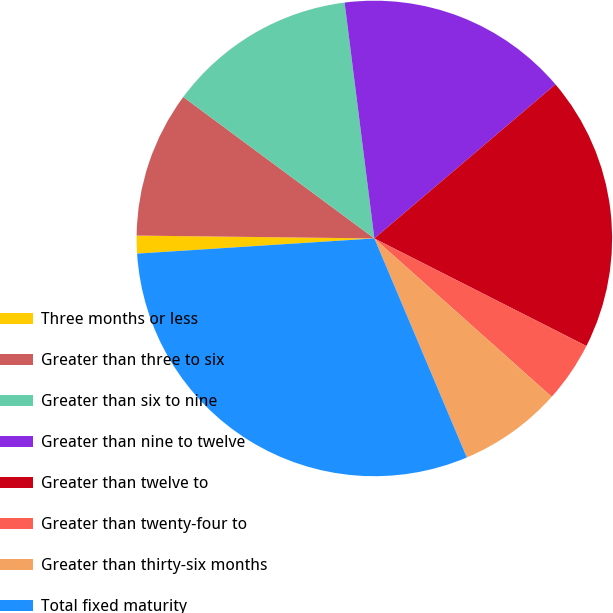<chart> <loc_0><loc_0><loc_500><loc_500><pie_chart><fcel>Three months or less<fcel>Greater than three to six<fcel>Greater than six to nine<fcel>Greater than nine to twelve<fcel>Greater than twelve to<fcel>Greater than twenty-four to<fcel>Greater than thirty-six months<fcel>Total fixed maturity<nl><fcel>1.21%<fcel>9.95%<fcel>12.86%<fcel>15.78%<fcel>18.69%<fcel>4.13%<fcel>7.04%<fcel>30.34%<nl></chart> 